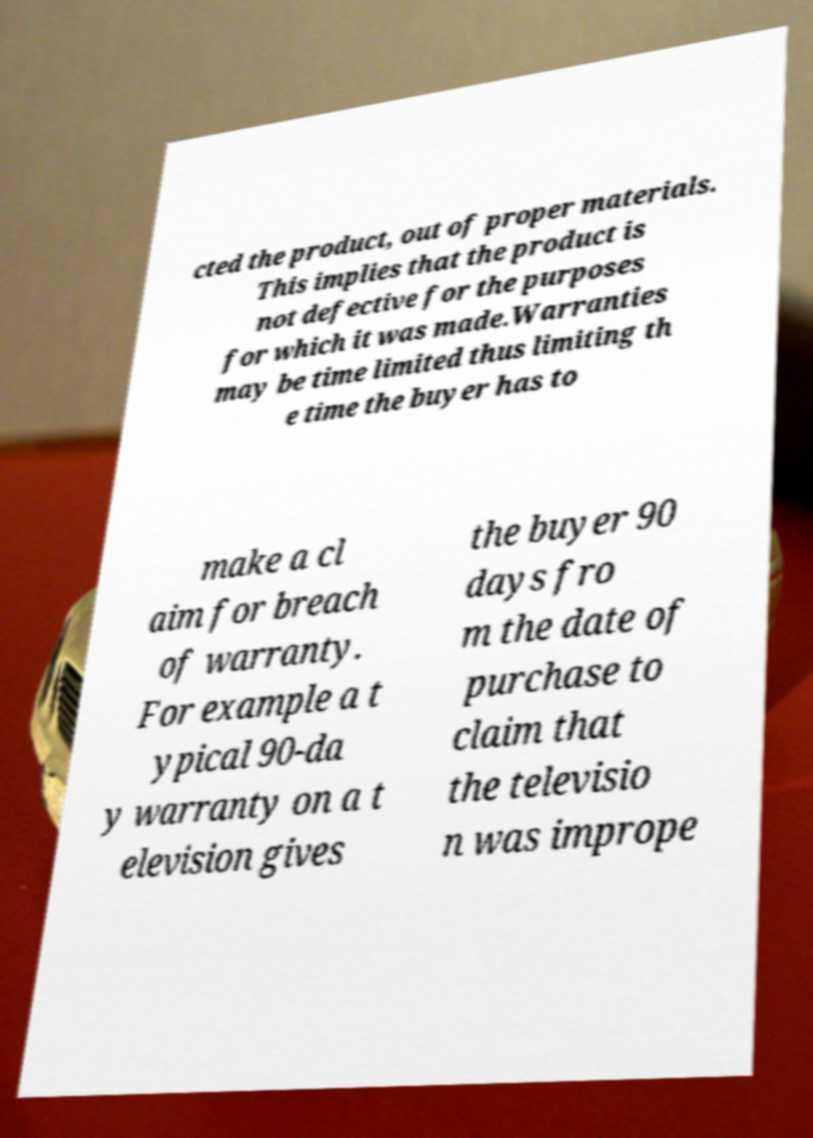Please read and relay the text visible in this image. What does it say? cted the product, out of proper materials. This implies that the product is not defective for the purposes for which it was made.Warranties may be time limited thus limiting th e time the buyer has to make a cl aim for breach of warranty. For example a t ypical 90-da y warranty on a t elevision gives the buyer 90 days fro m the date of purchase to claim that the televisio n was imprope 